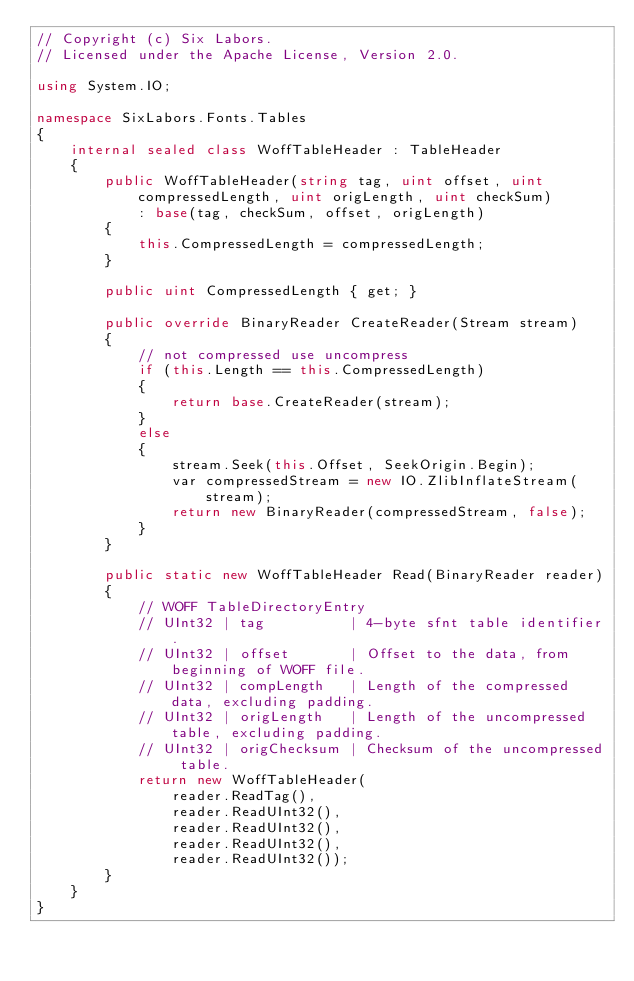Convert code to text. <code><loc_0><loc_0><loc_500><loc_500><_C#_>// Copyright (c) Six Labors.
// Licensed under the Apache License, Version 2.0.

using System.IO;

namespace SixLabors.Fonts.Tables
{
    internal sealed class WoffTableHeader : TableHeader
    {
        public WoffTableHeader(string tag, uint offset, uint compressedLength, uint origLength, uint checkSum)
            : base(tag, checkSum, offset, origLength)
        {
            this.CompressedLength = compressedLength;
        }

        public uint CompressedLength { get; }

        public override BinaryReader CreateReader(Stream stream)
        {
            // not compressed use uncompress
            if (this.Length == this.CompressedLength)
            {
                return base.CreateReader(stream);
            }
            else
            {
                stream.Seek(this.Offset, SeekOrigin.Begin);
                var compressedStream = new IO.ZlibInflateStream(stream);
                return new BinaryReader(compressedStream, false);
            }
        }

        public static new WoffTableHeader Read(BinaryReader reader)
        {
            // WOFF TableDirectoryEntry
            // UInt32 | tag          | 4-byte sfnt table identifier.
            // UInt32 | offset       | Offset to the data, from beginning of WOFF file.
            // UInt32 | compLength   | Length of the compressed data, excluding padding.
            // UInt32 | origLength   | Length of the uncompressed table, excluding padding.
            // UInt32 | origChecksum | Checksum of the uncompressed table.
            return new WoffTableHeader(
                reader.ReadTag(),
                reader.ReadUInt32(),
                reader.ReadUInt32(),
                reader.ReadUInt32(),
                reader.ReadUInt32());
        }
    }
}</code> 